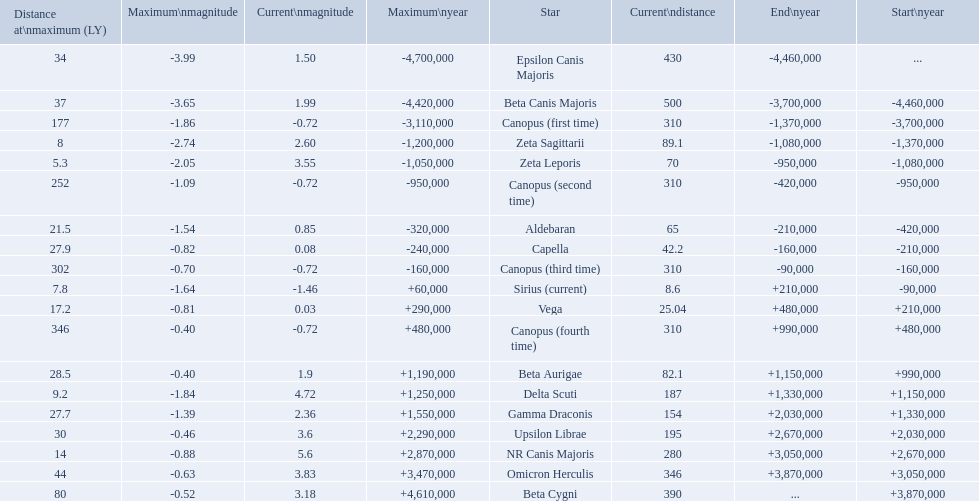What star has a a maximum magnitude of -0.63. Omicron Herculis. What star has a current distance of 390? Beta Cygni. 